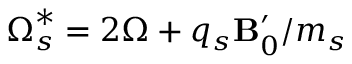<formula> <loc_0><loc_0><loc_500><loc_500>{ \boldsymbol \Omega _ { s } ^ { * } = 2 \boldsymbol \Omega + q _ { s } \mathbf B _ { 0 } ^ { \prime } / m _ { s } }</formula> 